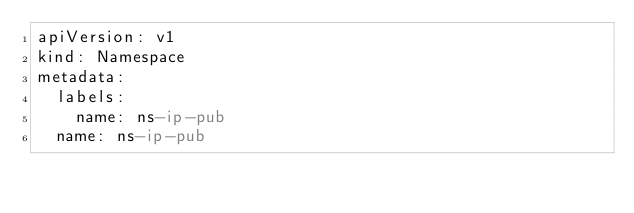<code> <loc_0><loc_0><loc_500><loc_500><_YAML_>apiVersion: v1
kind: Namespace
metadata:
  labels:
    name: ns-ip-pub
  name: ns-ip-pub
</code> 